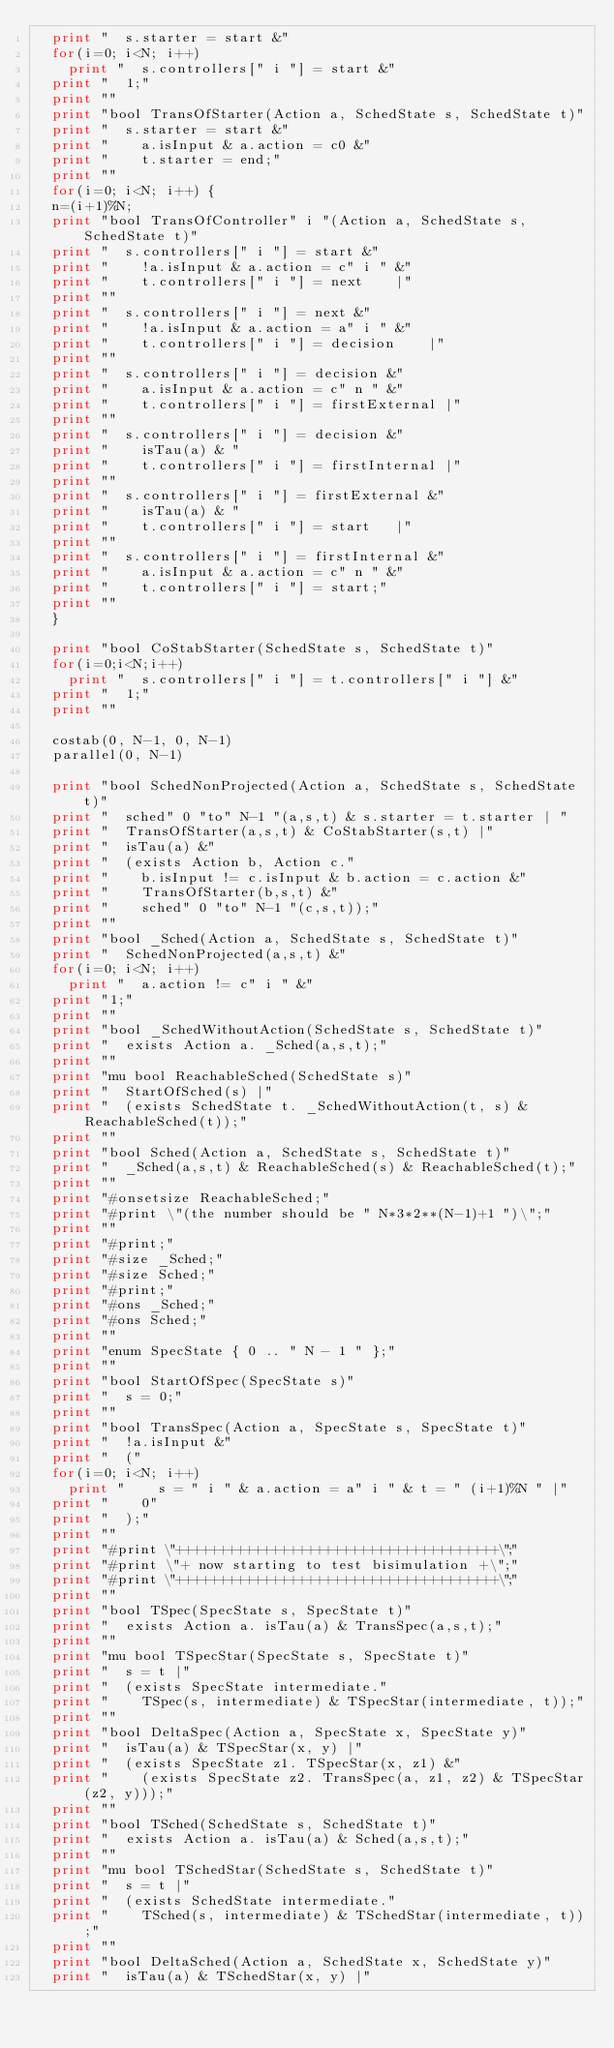<code> <loc_0><loc_0><loc_500><loc_500><_Awk_>  print "  s.starter = start &"
  for(i=0; i<N; i++)
    print "  s.controllers[" i "] = start &"
  print "  1;"
  print ""
  print "bool TransOfStarter(Action a, SchedState s, SchedState t)"
  print "  s.starter = start &"
  print "    a.isInput & a.action = c0 &"
  print "    t.starter = end;"
  print ""
  for(i=0; i<N; i++) {
  n=(i+1)%N;
  print "bool TransOfController" i "(Action a, SchedState s, SchedState t)"
  print "  s.controllers[" i "] = start &"
  print "    !a.isInput & a.action = c" i " &"
  print "    t.controllers[" i "] = next		|"
  print ""
  print "  s.controllers[" i "] = next &"
  print "    !a.isInput & a.action = a" i " &"
  print "    t.controllers[" i "] = decision		|"
  print ""
  print "  s.controllers[" i "] = decision &"
  print "    a.isInput & a.action = c" n " &"
  print "    t.controllers[" i "] = firstExternal	|"
  print ""
  print "  s.controllers[" i "] = decision &"
  print "    isTau(a) & "
  print "    t.controllers[" i "] = firstInternal	|"
  print ""
  print "  s.controllers[" i "] = firstExternal &"
  print "    isTau(a) & "
  print "    t.controllers[" i "] = start		|"
  print ""
  print "  s.controllers[" i "] = firstInternal &"
  print "    a.isInput & a.action = c" n " &"
  print "    t.controllers[" i "] = start;"
  print ""
  }

  print "bool CoStabStarter(SchedState s, SchedState t)"
  for(i=0;i<N;i++)
    print "  s.controllers[" i "] = t.controllers[" i "] &"
  print "  1;"
  print ""

  costab(0, N-1, 0, N-1)
  parallel(0, N-1)

  print "bool SchedNonProjected(Action a, SchedState s, SchedState t)"
  print "  sched" 0 "to" N-1 "(a,s,t) & s.starter = t.starter | "
  print "  TransOfStarter(a,s,t) & CoStabStarter(s,t) |"
  print "  isTau(a) &"
  print "  (exists Action b, Action c."
  print "    b.isInput != c.isInput & b.action = c.action &"
  print "    TransOfStarter(b,s,t) &"
  print "    sched" 0 "to" N-1 "(c,s,t));"
  print ""
  print "bool _Sched(Action a, SchedState s, SchedState t)"
  print "  SchedNonProjected(a,s,t) &"
  for(i=0; i<N; i++)
    print "  a.action != c" i " &"
  print "1;"
  print ""
  print "bool _SchedWithoutAction(SchedState s, SchedState t)"
  print "  exists Action a. _Sched(a,s,t);"
  print ""
  print "mu bool ReachableSched(SchedState s)"
  print "  StartOfSched(s) |"
  print "  (exists SchedState t. _SchedWithoutAction(t, s) & ReachableSched(t));"
  print ""
  print "bool Sched(Action a, SchedState s, SchedState t)"
  print "  _Sched(a,s,t) & ReachableSched(s) & ReachableSched(t);"
  print ""
  print "#onsetsize ReachableSched;"
  print "#print \"(the number should be " N*3*2**(N-1)+1 ")\";"
  print ""
  print "#print;"
  print "#size _Sched;"
  print "#size Sched;"
  print "#print;"
  print "#ons _Sched;"
  print "#ons Sched;"
  print ""
  print "enum SpecState { 0 .. " N - 1 " };"
  print ""
  print "bool StartOfSpec(SpecState s)"
  print "  s = 0;"
  print ""
  print "bool TransSpec(Action a, SpecState s, SpecState t)"
  print "  !a.isInput &"
  print "  ("
  for(i=0; i<N; i++)
    print "    s = " i " & a.action = a" i " & t = " (i+1)%N " |"
  print "    0"
  print "  );"
  print ""
  print "#print \"+++++++++++++++++++++++++++++++++++++\";"
  print "#print \"+ now starting to test bisimulation +\";"
  print "#print \"+++++++++++++++++++++++++++++++++++++\";"
  print ""
  print "bool TSpec(SpecState s, SpecState t)"
  print "  exists Action a. isTau(a) & TransSpec(a,s,t);"
  print ""
  print "mu bool TSpecStar(SpecState s, SpecState t)"
  print "  s = t |"
  print "  (exists SpecState intermediate."
  print "    TSpec(s, intermediate) & TSpecStar(intermediate, t));"
  print ""
  print "bool DeltaSpec(Action a, SpecState x, SpecState y)"
  print "  isTau(a) & TSpecStar(x, y) |"
  print "  (exists SpecState z1. TSpecStar(x, z1) &"
  print "    (exists SpecState z2. TransSpec(a, z1, z2) & TSpecStar(z2, y)));"
  print ""
  print "bool TSched(SchedState s, SchedState t)"
  print "  exists Action a. isTau(a) & Sched(a,s,t);"
  print ""
  print "mu bool TSchedStar(SchedState s, SchedState t)"
  print "  s = t |"
  print "  (exists SchedState intermediate."
  print "    TSched(s, intermediate) & TSchedStar(intermediate, t));"
  print ""
  print "bool DeltaSched(Action a, SchedState x, SchedState y)"
  print "  isTau(a) & TSchedStar(x, y) |"</code> 